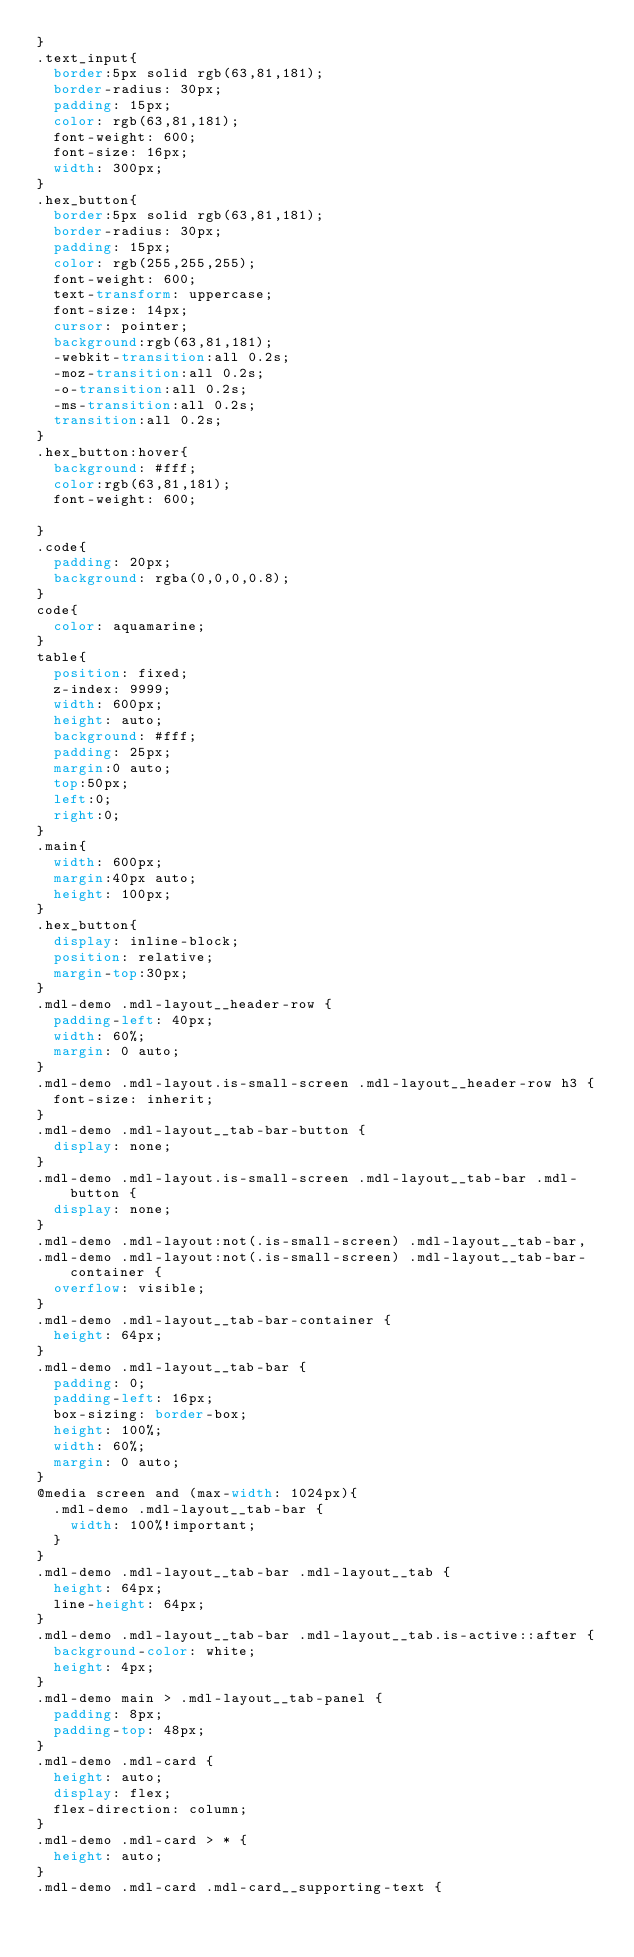Convert code to text. <code><loc_0><loc_0><loc_500><loc_500><_CSS_>}
.text_input{
  border:5px solid rgb(63,81,181);
  border-radius: 30px;
  padding: 15px;
  color: rgb(63,81,181);
  font-weight: 600;
  font-size: 16px;
  width: 300px;
}
.hex_button{
  border:5px solid rgb(63,81,181);
  border-radius: 30px;
  padding: 15px;
  color: rgb(255,255,255);
  font-weight: 600;
  text-transform: uppercase;
  font-size: 14px;
  cursor: pointer;
  background:rgb(63,81,181);
  -webkit-transition:all 0.2s;
  -moz-transition:all 0.2s;
  -o-transition:all 0.2s;
  -ms-transition:all 0.2s;
  transition:all 0.2s;
}
.hex_button:hover{
  background: #fff;
  color:rgb(63,81,181);
  font-weight: 600;

}
.code{
  padding: 20px;
  background: rgba(0,0,0,0.8);
}
code{
  color: aquamarine;
}
table{
  position: fixed;
  z-index: 9999;
  width: 600px;
  height: auto;
  background: #fff;
  padding: 25px;
  margin:0 auto;
  top:50px;
  left:0;
  right:0;
}
.main{
  width: 600px;
  margin:40px auto;
  height: 100px;
}
.hex_button{
  display: inline-block;
  position: relative;
  margin-top:30px;
}
.mdl-demo .mdl-layout__header-row {
  padding-left: 40px;
  width: 60%;
  margin: 0 auto;
}
.mdl-demo .mdl-layout.is-small-screen .mdl-layout__header-row h3 {
  font-size: inherit;
}
.mdl-demo .mdl-layout__tab-bar-button {
  display: none;
}
.mdl-demo .mdl-layout.is-small-screen .mdl-layout__tab-bar .mdl-button {
  display: none;
}
.mdl-demo .mdl-layout:not(.is-small-screen) .mdl-layout__tab-bar,
.mdl-demo .mdl-layout:not(.is-small-screen) .mdl-layout__tab-bar-container {
  overflow: visible;
}
.mdl-demo .mdl-layout__tab-bar-container {
  height: 64px;
}
.mdl-demo .mdl-layout__tab-bar {
  padding: 0;
  padding-left: 16px;
  box-sizing: border-box;
  height: 100%;
  width: 60%;
  margin: 0 auto;
}
@media screen and (max-width: 1024px){
  .mdl-demo .mdl-layout__tab-bar {
    width: 100%!important;
  }
}
.mdl-demo .mdl-layout__tab-bar .mdl-layout__tab {
  height: 64px;
  line-height: 64px;
}
.mdl-demo .mdl-layout__tab-bar .mdl-layout__tab.is-active::after {
  background-color: white;
  height: 4px;
}
.mdl-demo main > .mdl-layout__tab-panel {
  padding: 8px;
  padding-top: 48px;
}
.mdl-demo .mdl-card {
  height: auto;
  display: flex;
  flex-direction: column;
}
.mdl-demo .mdl-card > * {
  height: auto;
}
.mdl-demo .mdl-card .mdl-card__supporting-text {</code> 